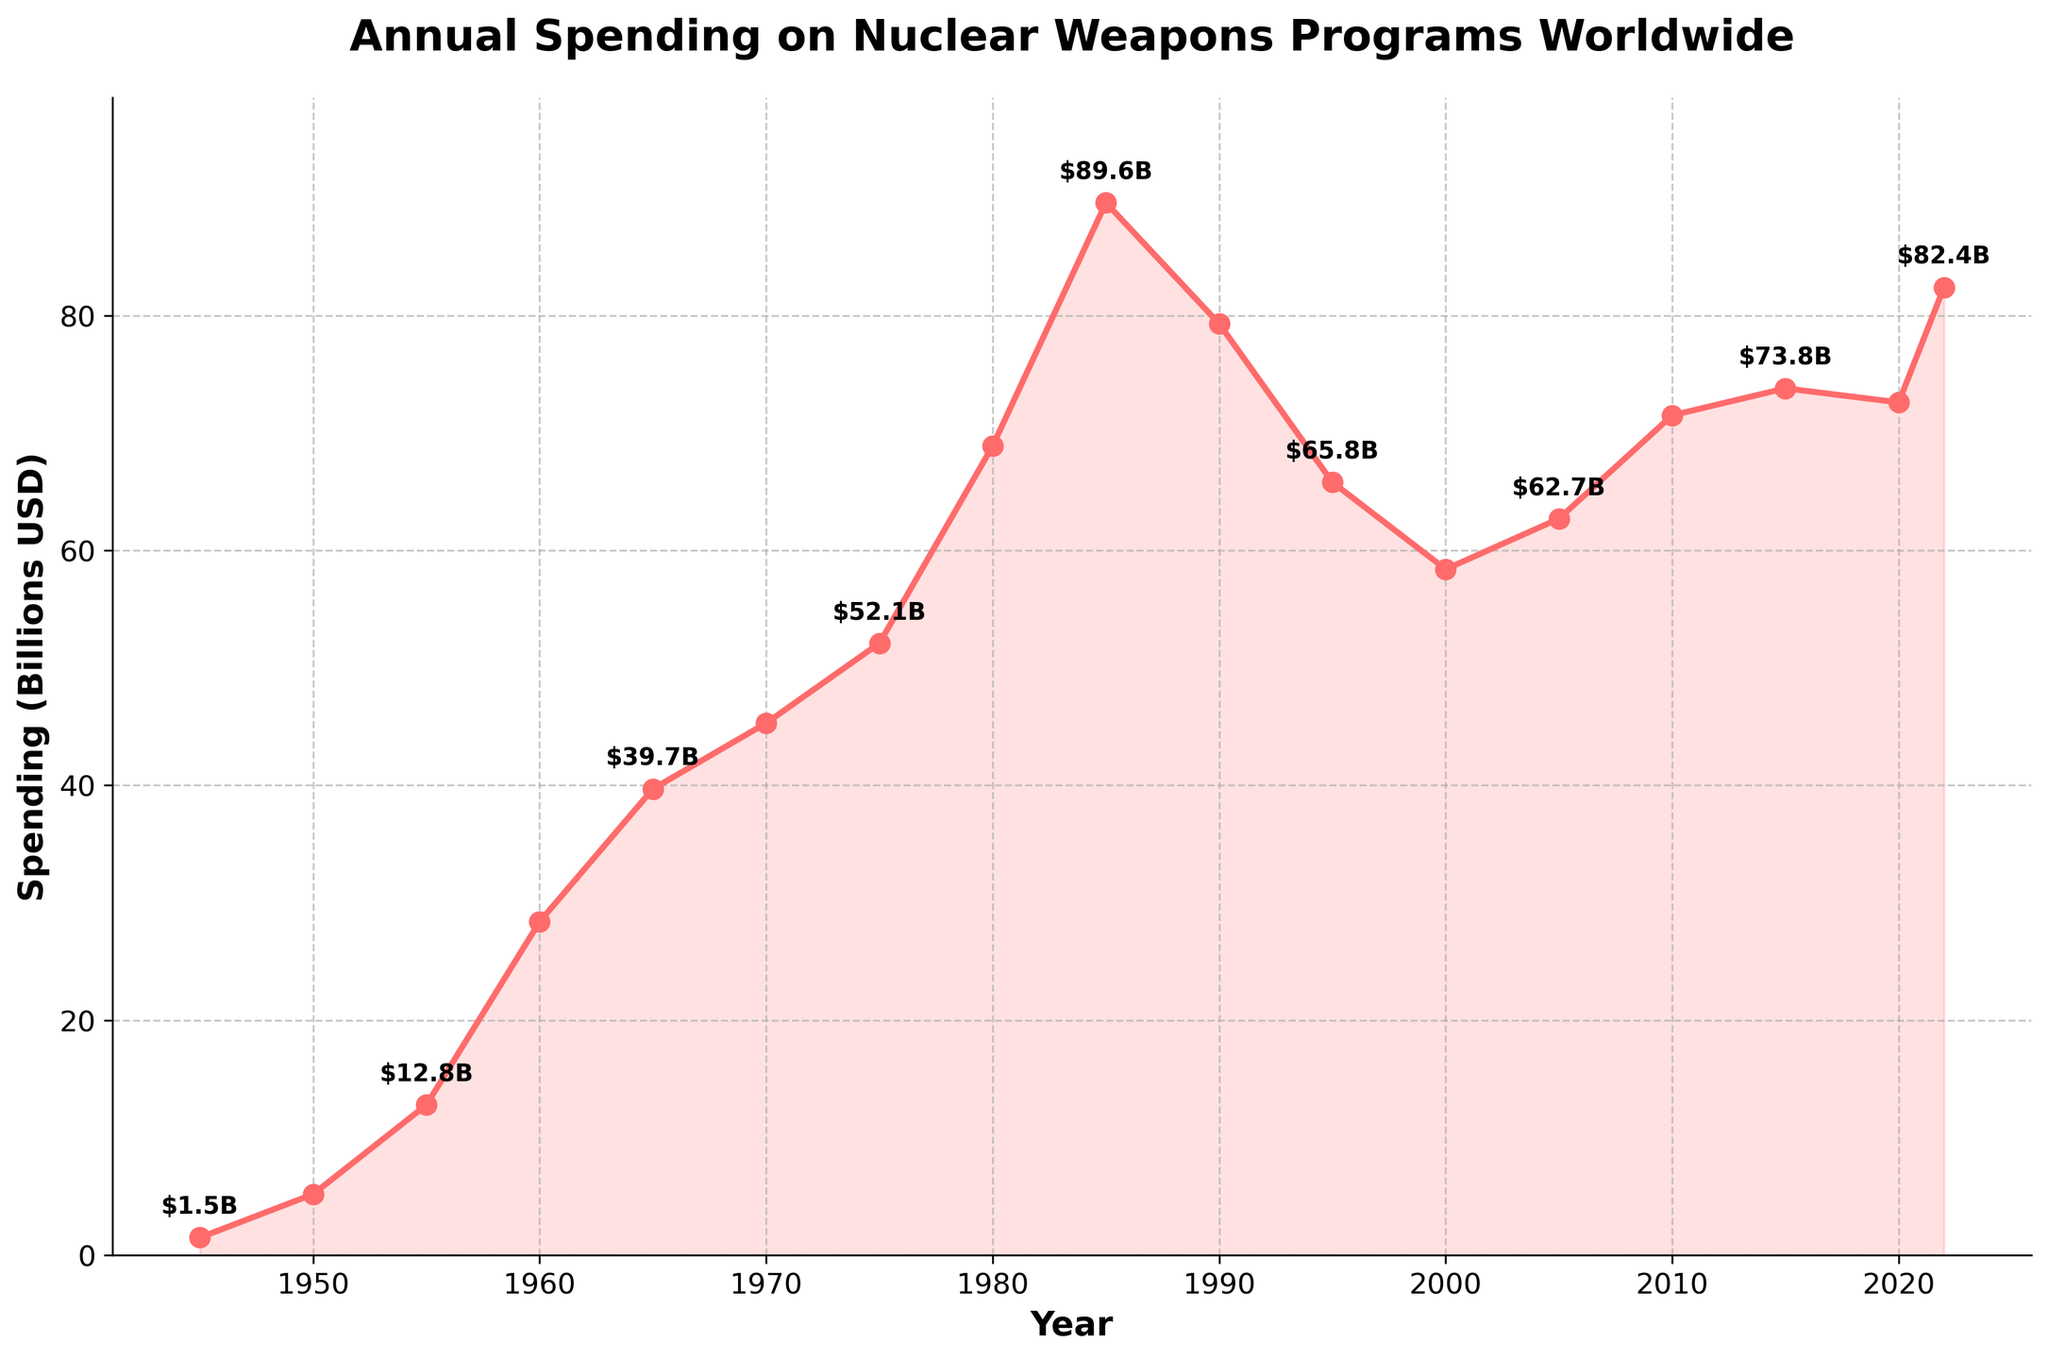What is the annual spending on nuclear weapons programs in 1980? Look at the data point for the year 1980 in the figure. The spending is marked and labeled at approximately 68.9 billion USD.
Answer: 68.9 billion USD Between which two consecutive years did the annual spending on nuclear weapons programs see the largest increase? To find this, look for the steepest upward slope between any two consecutive points in the line chart. The biggest increase occurs between 1980 and 1985, where spending jumped from 68.9 billion USD to 89.6 billion USD, an increase of 20.7 billion USD.
Answer: 1980 and 1985 What was the total spending on nuclear weapons programs from 1945 to 1955? Total spending is the sum of the values for 1945, 1950, and 1955. Adding 1.5, 5.2, and 12.8 gives us 19.5 billion USD.
Answer: 19.5 billion USD During which decade did the annual spending on nuclear weapons programs decrease the most? From the figure, the largest decrease can be seen between 1985 and 1995. In 1985, the spending was 89.6 billion USD and it decreased to 65.8 billion USD in 1995. The decrease is 23.8 billion USD.
Answer: 1985 to 1995 How does the spending in 2022 compare to that in 1990? Observe and compare the data points for the years 2022 (82.4 billion USD) and 1990 (79.3 billion USD). The spending in 2022 is slightly higher.
Answer: 2022 is higher What is the average annual spending on nuclear weapons programs based on the data provided? To find the average, sum all yearly spending values and divide by the number of years. Summing the values from 1945 to 2022, we get 909.9 billion USD over 17 years. 909.9 / 17 is approximately 53.5 billion USD.
Answer: 53.5 billion USD What is the overall trend in nuclear weapons program spending from 1945 to 2022? The figure shows a general increasing trend from 1945 to 2022 with some fluctuations. The spending rapidly increased from 1945 to the mid-80s, then saw a decrease in the 90s, before rising again in the 2000s.
Answer: Increasing trend Which year had the maximum spending on nuclear weapons programs according to the figure? Look for the highest data point in the line chart. The maximum spending occurred in 1985 with 89.6 billion USD.
Answer: 1985 By how much did the spending decrease from its peak in 1985 to its lowest point in the next decade? The peak spending in 1985 was 89.6 billion USD. The lowest point in the subsequent decade is in 1995 with 65.8 billion USD. The decrease is 89.6 - 65.8 = 23.8 billion USD.
Answer: 23.8 billion USD 